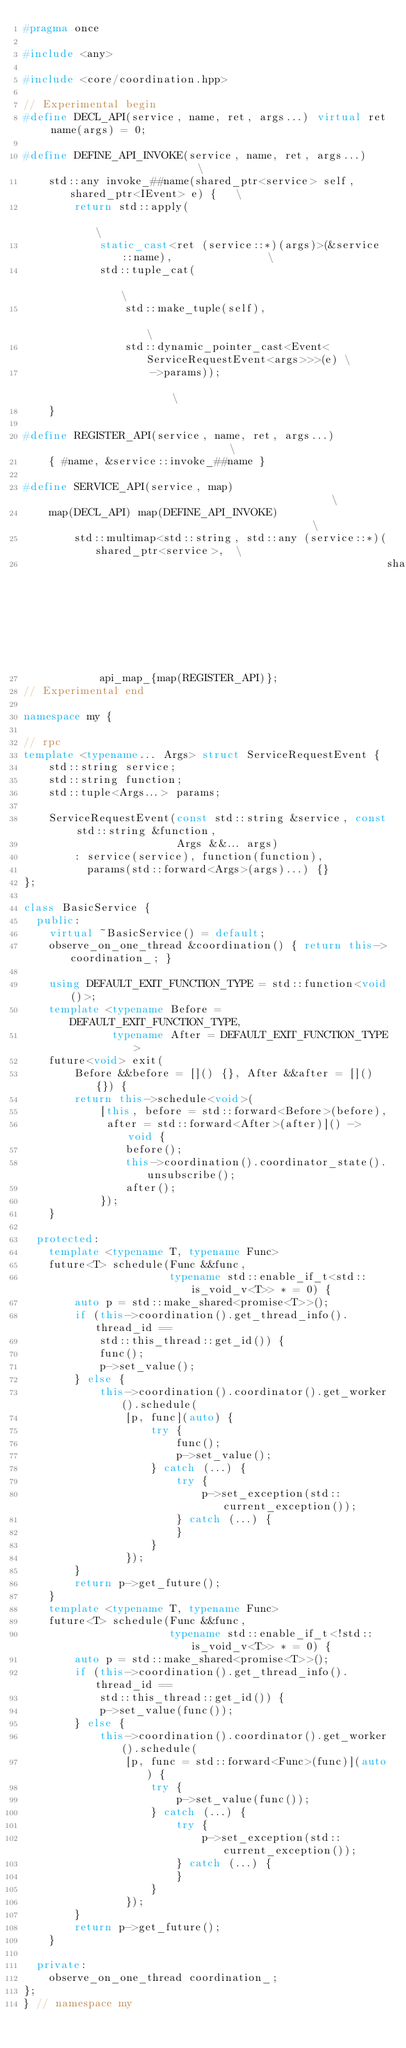Convert code to text. <code><loc_0><loc_0><loc_500><loc_500><_C++_>#pragma once

#include <any>

#include <core/coordination.hpp>

// Experimental begin
#define DECL_API(service, name, ret, args...) virtual ret name(args) = 0;

#define DEFINE_API_INVOKE(service, name, ret, args...)                         \
    std::any invoke_##name(shared_ptr<service> self, shared_ptr<IEvent> e) {   \
        return std::apply(                                                     \
            static_cast<ret (service::*)(args)>(&service::name),               \
            std::tuple_cat(                                                    \
                std::make_tuple(self),                                         \
                std::dynamic_pointer_cast<Event<ServiceRequestEvent<args>>>(e) \
                    ->params));                                                \
    }

#define REGISTER_API(service, name, ret, args...)                              \
    { #name, &service::invoke_##name }

#define SERVICE_API(service, map)                                              \
    map(DECL_API) map(DEFINE_API_INVOKE)                                       \
        std::multimap<std::string, std::any (service::*)(shared_ptr<service>,  \
                                                         shared_ptr<IEvent>)>  \
            api_map_{map(REGISTER_API)};
// Experimental end

namespace my {

// rpc
template <typename... Args> struct ServiceRequestEvent {
    std::string service;
    std::string function;
    std::tuple<Args...> params;

    ServiceRequestEvent(const std::string &service, const std::string &function,
                        Args &&... args)
        : service(service), function(function),
          params(std::forward<Args>(args)...) {}
};

class BasicService {
  public:
    virtual ~BasicService() = default;
    observe_on_one_thread &coordination() { return this->coordination_; }

    using DEFAULT_EXIT_FUNCTION_TYPE = std::function<void()>;
    template <typename Before = DEFAULT_EXIT_FUNCTION_TYPE,
              typename After = DEFAULT_EXIT_FUNCTION_TYPE>
    future<void> exit(
        Before &&before = []() {}, After &&after = []() {}) {
        return this->schedule<void>(
            [this, before = std::forward<Before>(before),
             after = std::forward<After>(after)]() -> void {
                before();
                this->coordination().coordinator_state().unsubscribe();
                after();
            });
    }

  protected:
    template <typename T, typename Func>
    future<T> schedule(Func &&func,
                       typename std::enable_if_t<std::is_void_v<T>> * = 0) {
        auto p = std::make_shared<promise<T>>();
        if (this->coordination().get_thread_info().thread_id ==
            std::this_thread::get_id()) {
            func();
            p->set_value();
        } else {
            this->coordination().coordinator().get_worker().schedule(
                [p, func](auto) {
                    try {
                        func();
                        p->set_value();
                    } catch (...) {
                        try {
                            p->set_exception(std::current_exception());
                        } catch (...) {
                        }
                    }
                });
        }
        return p->get_future();
    }
    template <typename T, typename Func>
    future<T> schedule(Func &&func,
                       typename std::enable_if_t<!std::is_void_v<T>> * = 0) {
        auto p = std::make_shared<promise<T>>();
        if (this->coordination().get_thread_info().thread_id ==
            std::this_thread::get_id()) {
            p->set_value(func());
        } else {
            this->coordination().coordinator().get_worker().schedule(
                [p, func = std::forward<Func>(func)](auto) {
                    try {
                        p->set_value(func());
                    } catch (...) {
                        try {
                            p->set_exception(std::current_exception());
                        } catch (...) {
                        }
                    }
                });
        }
        return p->get_future();
    }

  private:
    observe_on_one_thread coordination_;
};
} // namespace my
</code> 